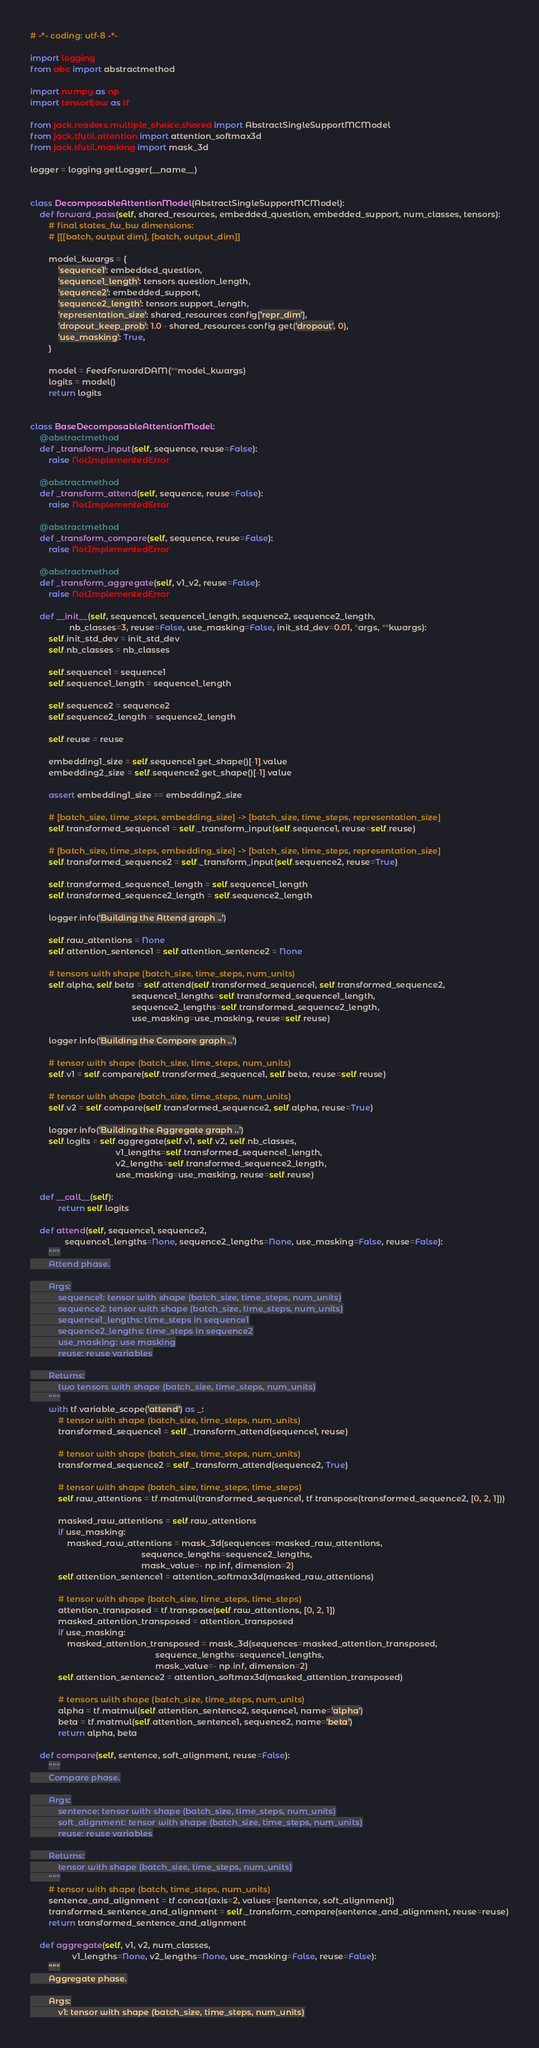Convert code to text. <code><loc_0><loc_0><loc_500><loc_500><_Python_># -*- coding: utf-8 -*-

import logging
from abc import abstractmethod

import numpy as np
import tensorflow as tf

from jack.readers.multiple_choice.shared import AbstractSingleSupportMCModel
from jack.tfutil.attention import attention_softmax3d
from jack.tfutil.masking import mask_3d

logger = logging.getLogger(__name__)


class DecomposableAttentionModel(AbstractSingleSupportMCModel):
    def forward_pass(self, shared_resources, embedded_question, embedded_support, num_classes, tensors):
        # final states_fw_bw dimensions:
        # [[[batch, output dim], [batch, output_dim]]

        model_kwargs = {
            'sequence1': embedded_question,
            'sequence1_length': tensors.question_length,
            'sequence2': embedded_support,
            'sequence2_length': tensors.support_length,
            'representation_size': shared_resources.config['repr_dim'],
            'dropout_keep_prob': 1.0 - shared_resources.config.get('dropout', 0),
            'use_masking': True,
        }

        model = FeedForwardDAM(**model_kwargs)
        logits = model()
        return logits


class BaseDecomposableAttentionModel:
    @abstractmethod
    def _transform_input(self, sequence, reuse=False):
        raise NotImplementedError

    @abstractmethod
    def _transform_attend(self, sequence, reuse=False):
        raise NotImplementedError

    @abstractmethod
    def _transform_compare(self, sequence, reuse=False):
        raise NotImplementedError

    @abstractmethod
    def _transform_aggregate(self, v1_v2, reuse=False):
        raise NotImplementedError

    def __init__(self, sequence1, sequence1_length, sequence2, sequence2_length,
                 nb_classes=3, reuse=False, use_masking=False, init_std_dev=0.01, *args, **kwargs):
        self.init_std_dev = init_std_dev
        self.nb_classes = nb_classes

        self.sequence1 = sequence1
        self.sequence1_length = sequence1_length

        self.sequence2 = sequence2
        self.sequence2_length = sequence2_length

        self.reuse = reuse

        embedding1_size = self.sequence1.get_shape()[-1].value
        embedding2_size = self.sequence2.get_shape()[-1].value

        assert embedding1_size == embedding2_size

        # [batch_size, time_steps, embedding_size] -> [batch_size, time_steps, representation_size]
        self.transformed_sequence1 = self._transform_input(self.sequence1, reuse=self.reuse)

        # [batch_size, time_steps, embedding_size] -> [batch_size, time_steps, representation_size]
        self.transformed_sequence2 = self._transform_input(self.sequence2, reuse=True)

        self.transformed_sequence1_length = self.sequence1_length
        self.transformed_sequence2_length = self.sequence2_length

        logger.info('Building the Attend graph ..')

        self.raw_attentions = None
        self.attention_sentence1 = self.attention_sentence2 = None

        # tensors with shape (batch_size, time_steps, num_units)
        self.alpha, self.beta = self.attend(self.transformed_sequence1, self.transformed_sequence2,
                                            sequence1_lengths=self.transformed_sequence1_length,
                                            sequence2_lengths=self.transformed_sequence2_length,
                                            use_masking=use_masking, reuse=self.reuse)

        logger.info('Building the Compare graph ..')

        # tensor with shape (batch_size, time_steps, num_units)
        self.v1 = self.compare(self.transformed_sequence1, self.beta, reuse=self.reuse)

        # tensor with shape (batch_size, time_steps, num_units)
        self.v2 = self.compare(self.transformed_sequence2, self.alpha, reuse=True)

        logger.info('Building the Aggregate graph ..')
        self.logits = self.aggregate(self.v1, self.v2, self.nb_classes,
                                     v1_lengths=self.transformed_sequence1_length,
                                     v2_lengths=self.transformed_sequence2_length,
                                     use_masking=use_masking, reuse=self.reuse)

    def __call__(self):
            return self.logits

    def attend(self, sequence1, sequence2,
               sequence1_lengths=None, sequence2_lengths=None, use_masking=False, reuse=False):
        """
        Attend phase.

        Args:
            sequence1: tensor with shape (batch_size, time_steps, num_units)
            sequence2: tensor with shape (batch_size, time_steps, num_units)
            sequence1_lengths: time_steps in sequence1
            sequence2_lengths: time_steps in sequence2
            use_masking: use masking
            reuse: reuse variables

        Returns:
            two tensors with shape (batch_size, time_steps, num_units)
        """
        with tf.variable_scope('attend') as _:
            # tensor with shape (batch_size, time_steps, num_units)
            transformed_sequence1 = self._transform_attend(sequence1, reuse)

            # tensor with shape (batch_size, time_steps, num_units)
            transformed_sequence2 = self._transform_attend(sequence2, True)

            # tensor with shape (batch_size, time_steps, time_steps)
            self.raw_attentions = tf.matmul(transformed_sequence1, tf.transpose(transformed_sequence2, [0, 2, 1]))

            masked_raw_attentions = self.raw_attentions
            if use_masking:
                masked_raw_attentions = mask_3d(sequences=masked_raw_attentions,
                                                sequence_lengths=sequence2_lengths,
                                                mask_value=- np.inf, dimension=2)
            self.attention_sentence1 = attention_softmax3d(masked_raw_attentions)

            # tensor with shape (batch_size, time_steps, time_steps)
            attention_transposed = tf.transpose(self.raw_attentions, [0, 2, 1])
            masked_attention_transposed = attention_transposed
            if use_masking:
                masked_attention_transposed = mask_3d(sequences=masked_attention_transposed,
                                                      sequence_lengths=sequence1_lengths,
                                                      mask_value=- np.inf, dimension=2)
            self.attention_sentence2 = attention_softmax3d(masked_attention_transposed)

            # tensors with shape (batch_size, time_steps, num_units)
            alpha = tf.matmul(self.attention_sentence2, sequence1, name='alpha')
            beta = tf.matmul(self.attention_sentence1, sequence2, name='beta')
            return alpha, beta

    def compare(self, sentence, soft_alignment, reuse=False):
        """
        Compare phase.

        Args:
            sentence: tensor with shape (batch_size, time_steps, num_units)
            soft_alignment: tensor with shape (batch_size, time_steps, num_units)
            reuse: reuse variables

        Returns:
            tensor with shape (batch_size, time_steps, num_units)
        """
        # tensor with shape (batch, time_steps, num_units)
        sentence_and_alignment = tf.concat(axis=2, values=[sentence, soft_alignment])
        transformed_sentence_and_alignment = self._transform_compare(sentence_and_alignment, reuse=reuse)
        return transformed_sentence_and_alignment

    def aggregate(self, v1, v2, num_classes,
                  v1_lengths=None, v2_lengths=None, use_masking=False, reuse=False):
        """
        Aggregate phase.

        Args:
            v1: tensor with shape (batch_size, time_steps, num_units)</code> 